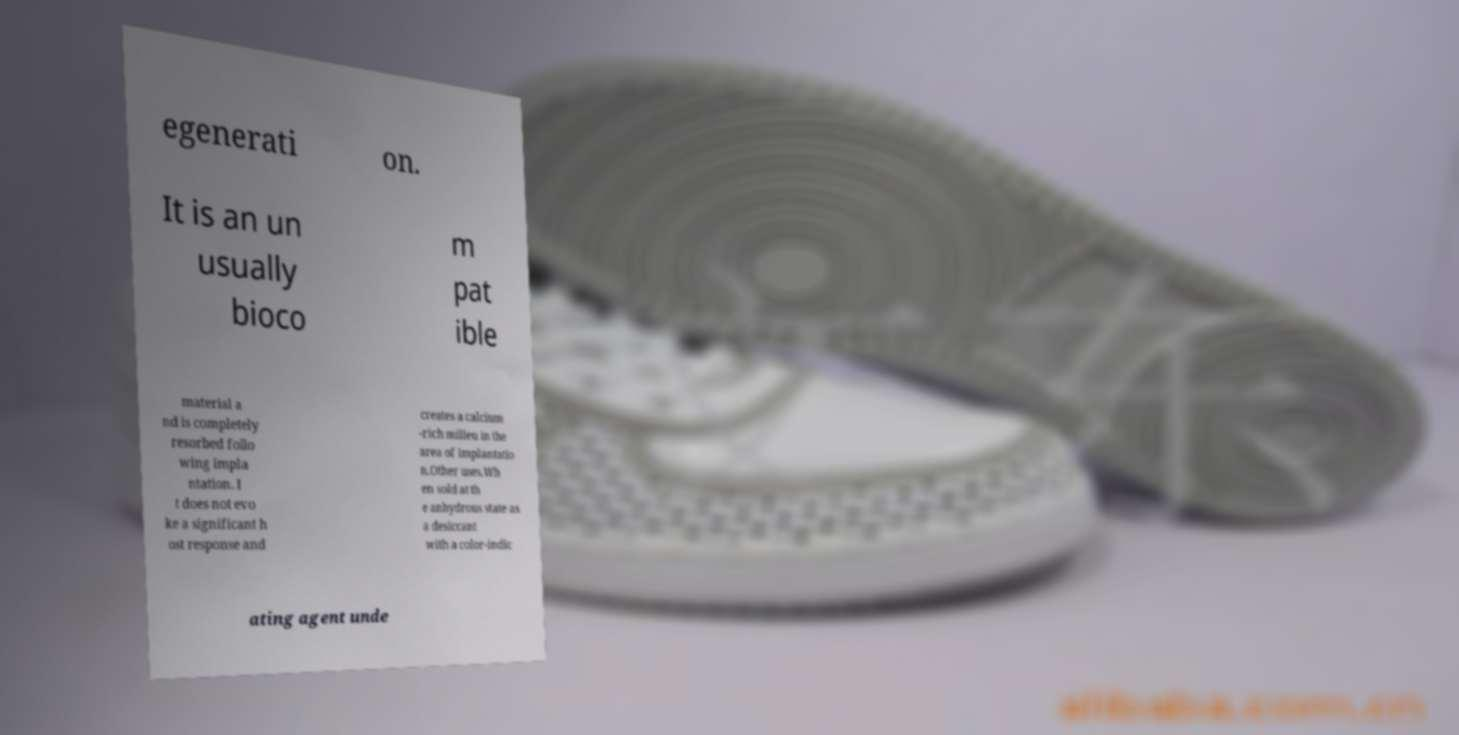Please identify and transcribe the text found in this image. egenerati on. It is an un usually bioco m pat ible material a nd is completely resorbed follo wing impla ntation. I t does not evo ke a significant h ost response and creates a calcium -rich milieu in the area of implantatio n.Other uses.Wh en sold at th e anhydrous state as a desiccant with a color-indic ating agent unde 